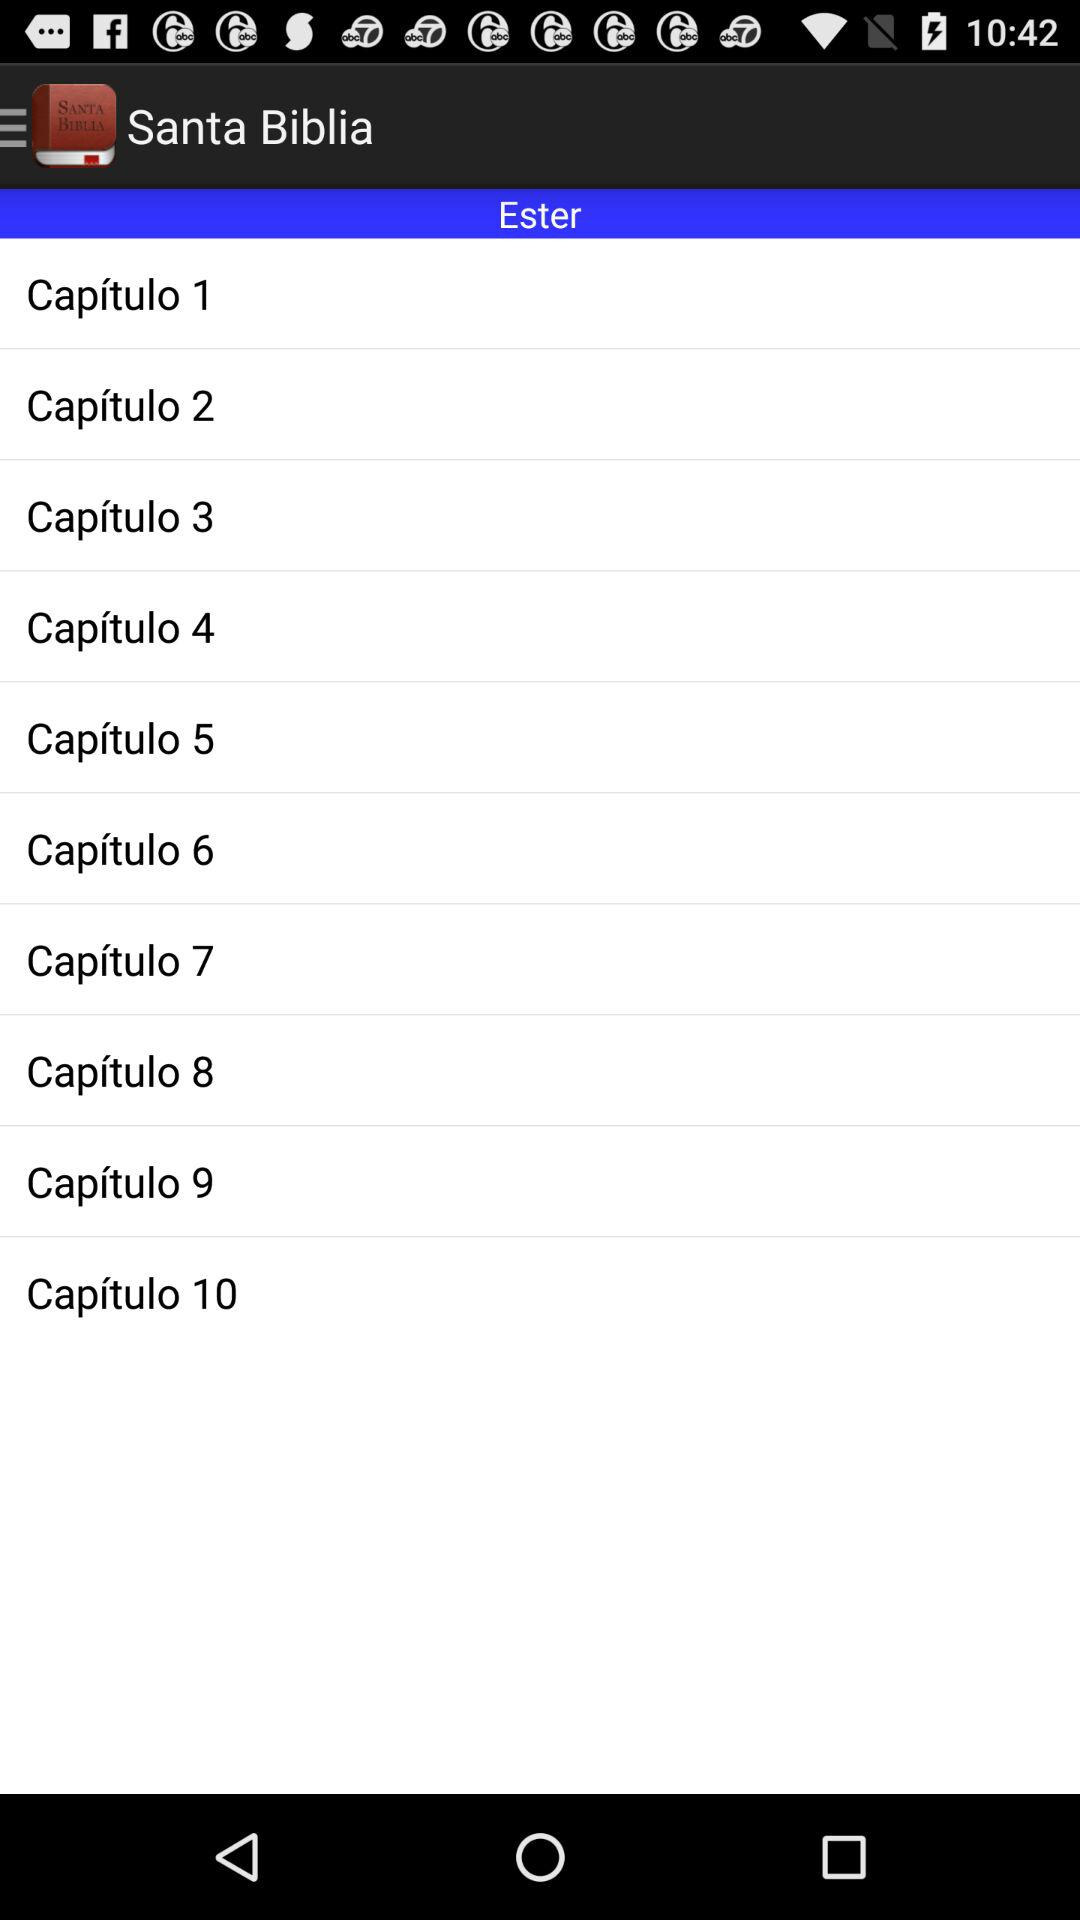How many chapters are there in the book of Esther?
Answer the question using a single word or phrase. 10 